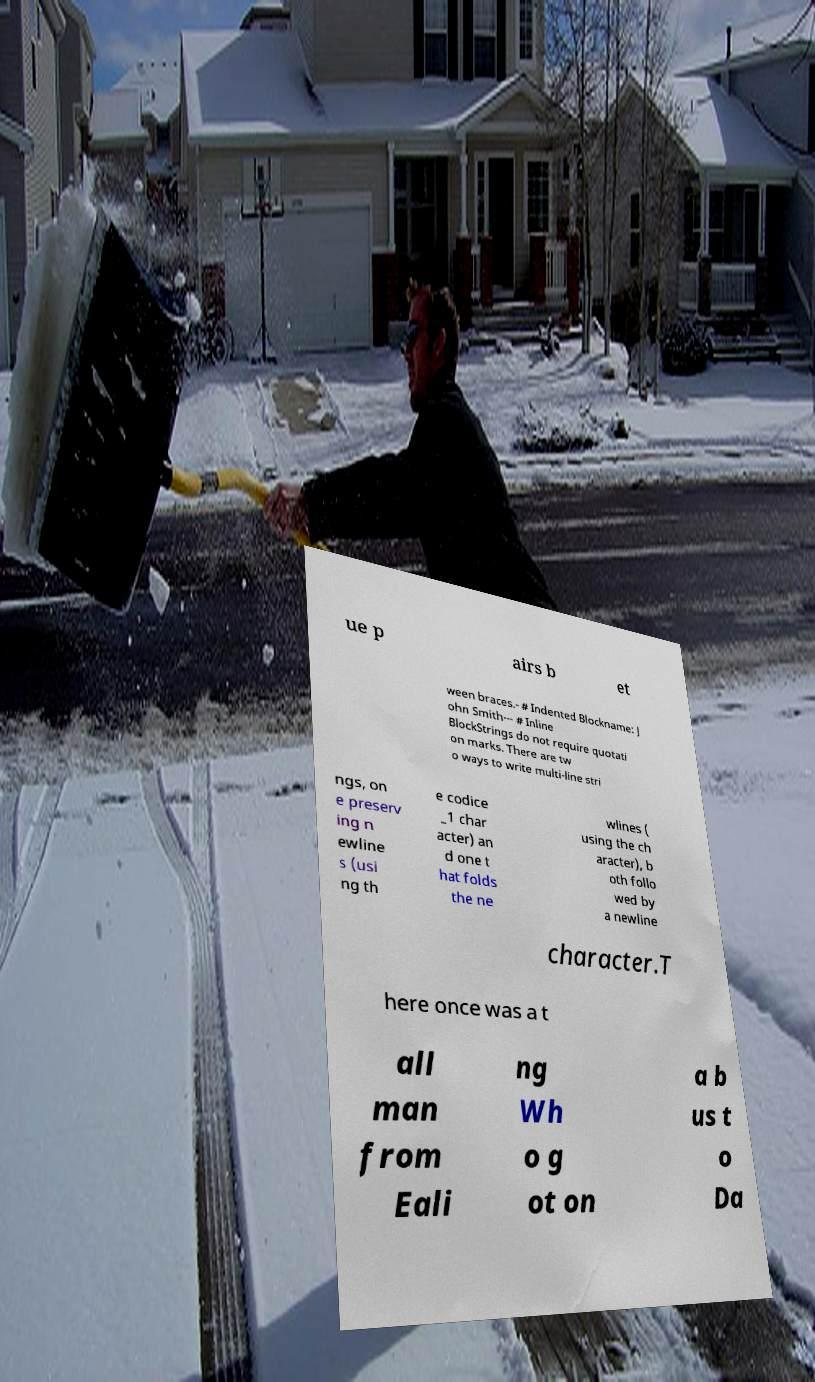Please identify and transcribe the text found in this image. ue p airs b et ween braces.- # Indented Blockname: J ohn Smith--- # Inline BlockStrings do not require quotati on marks. There are tw o ways to write multi-line stri ngs, on e preserv ing n ewline s (usi ng th e codice _1 char acter) an d one t hat folds the ne wlines ( using the ch aracter), b oth follo wed by a newline character.T here once was a t all man from Eali ng Wh o g ot on a b us t o Da 